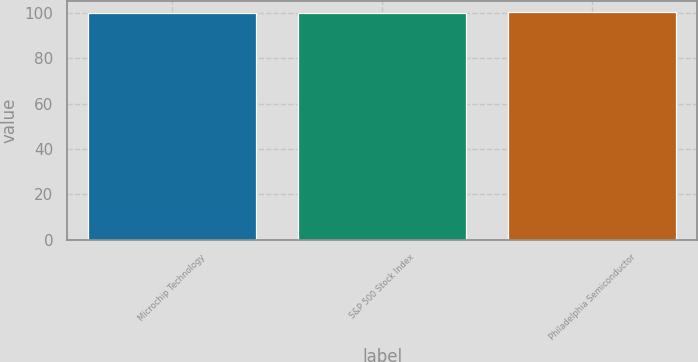Convert chart. <chart><loc_0><loc_0><loc_500><loc_500><bar_chart><fcel>Microchip Technology<fcel>S&P 500 Stock Index<fcel>Philadelphia Semiconductor<nl><fcel>100<fcel>100.1<fcel>100.2<nl></chart> 